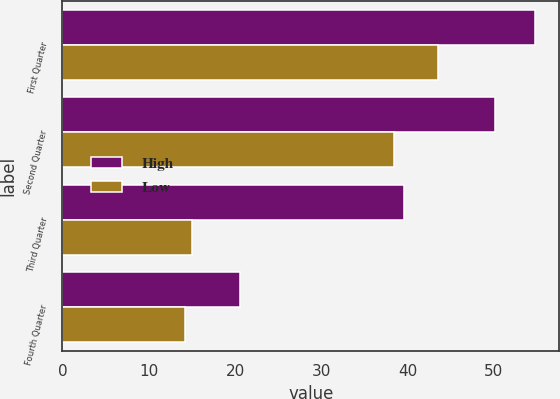Convert chart. <chart><loc_0><loc_0><loc_500><loc_500><stacked_bar_chart><ecel><fcel>First Quarter<fcel>Second Quarter<fcel>Third Quarter<fcel>Fourth Quarter<nl><fcel>High<fcel>54.81<fcel>50.17<fcel>39.56<fcel>20.6<nl><fcel>Low<fcel>43.46<fcel>38.36<fcel>15.01<fcel>14.24<nl></chart> 